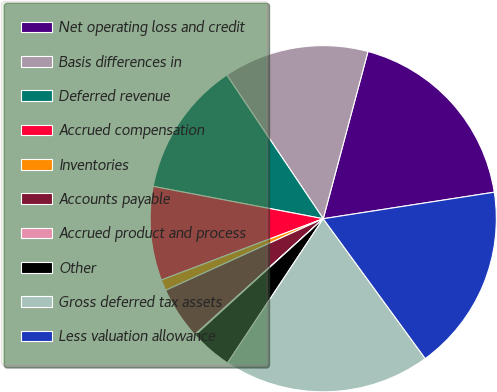Convert chart. <chart><loc_0><loc_0><loc_500><loc_500><pie_chart><fcel>Net operating loss and credit<fcel>Basis differences in<fcel>Deferred revenue<fcel>Accrued compensation<fcel>Inventories<fcel>Accounts payable<fcel>Accrued product and process<fcel>Other<fcel>Gross deferred tax assets<fcel>Less valuation allowance<nl><fcel>18.39%<fcel>13.57%<fcel>12.6%<fcel>8.75%<fcel>1.03%<fcel>4.89%<fcel>0.07%<fcel>3.93%<fcel>19.35%<fcel>17.42%<nl></chart> 